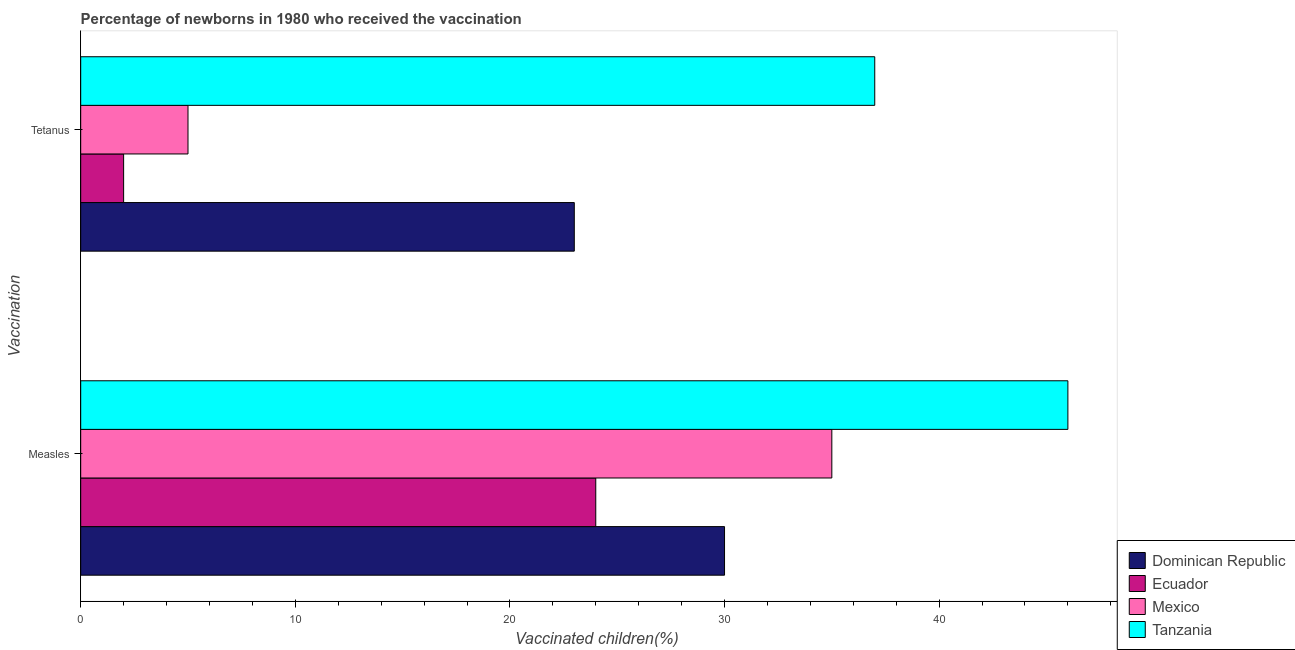How many different coloured bars are there?
Offer a terse response. 4. How many groups of bars are there?
Give a very brief answer. 2. Are the number of bars on each tick of the Y-axis equal?
Make the answer very short. Yes. How many bars are there on the 2nd tick from the bottom?
Provide a short and direct response. 4. What is the label of the 1st group of bars from the top?
Provide a short and direct response. Tetanus. What is the percentage of newborns who received vaccination for tetanus in Tanzania?
Make the answer very short. 37. Across all countries, what is the maximum percentage of newborns who received vaccination for measles?
Offer a terse response. 46. Across all countries, what is the minimum percentage of newborns who received vaccination for tetanus?
Give a very brief answer. 2. In which country was the percentage of newborns who received vaccination for tetanus maximum?
Ensure brevity in your answer.  Tanzania. In which country was the percentage of newborns who received vaccination for measles minimum?
Ensure brevity in your answer.  Ecuador. What is the total percentage of newborns who received vaccination for measles in the graph?
Give a very brief answer. 135. What is the difference between the percentage of newborns who received vaccination for tetanus in Dominican Republic and that in Mexico?
Keep it short and to the point. 18. What is the difference between the percentage of newborns who received vaccination for measles in Ecuador and the percentage of newborns who received vaccination for tetanus in Tanzania?
Keep it short and to the point. -13. What is the average percentage of newborns who received vaccination for measles per country?
Provide a succinct answer. 33.75. What is the difference between the percentage of newborns who received vaccination for measles and percentage of newborns who received vaccination for tetanus in Tanzania?
Offer a very short reply. 9. What is the ratio of the percentage of newborns who received vaccination for measles in Ecuador to that in Tanzania?
Your response must be concise. 0.52. Is the percentage of newborns who received vaccination for tetanus in Dominican Republic less than that in Tanzania?
Keep it short and to the point. Yes. What does the 2nd bar from the bottom in Tetanus represents?
Provide a short and direct response. Ecuador. Does the graph contain any zero values?
Keep it short and to the point. No. Where does the legend appear in the graph?
Your answer should be very brief. Bottom right. How are the legend labels stacked?
Make the answer very short. Vertical. What is the title of the graph?
Give a very brief answer. Percentage of newborns in 1980 who received the vaccination. What is the label or title of the X-axis?
Your answer should be compact. Vaccinated children(%)
. What is the label or title of the Y-axis?
Make the answer very short. Vaccination. What is the Vaccinated children(%)
 in Dominican Republic in Measles?
Ensure brevity in your answer.  30. What is the Vaccinated children(%)
 in Ecuador in Measles?
Give a very brief answer. 24. What is the Vaccinated children(%)
 in Mexico in Measles?
Your response must be concise. 35. Across all Vaccination, what is the maximum Vaccinated children(%)
 of Dominican Republic?
Keep it short and to the point. 30. Across all Vaccination, what is the minimum Vaccinated children(%)
 of Dominican Republic?
Keep it short and to the point. 23. Across all Vaccination, what is the minimum Vaccinated children(%)
 of Tanzania?
Offer a very short reply. 37. What is the total Vaccinated children(%)
 of Dominican Republic in the graph?
Offer a very short reply. 53. What is the total Vaccinated children(%)
 in Ecuador in the graph?
Your answer should be very brief. 26. What is the total Vaccinated children(%)
 in Mexico in the graph?
Make the answer very short. 40. What is the difference between the Vaccinated children(%)
 in Dominican Republic in Measles and that in Tetanus?
Provide a succinct answer. 7. What is the difference between the Vaccinated children(%)
 in Mexico in Measles and that in Tetanus?
Provide a short and direct response. 30. What is the difference between the Vaccinated children(%)
 in Dominican Republic in Measles and the Vaccinated children(%)
 in Ecuador in Tetanus?
Provide a short and direct response. 28. What is the difference between the Vaccinated children(%)
 of Ecuador in Measles and the Vaccinated children(%)
 of Mexico in Tetanus?
Your answer should be very brief. 19. What is the average Vaccinated children(%)
 of Dominican Republic per Vaccination?
Offer a very short reply. 26.5. What is the average Vaccinated children(%)
 of Ecuador per Vaccination?
Give a very brief answer. 13. What is the average Vaccinated children(%)
 of Mexico per Vaccination?
Your answer should be compact. 20. What is the average Vaccinated children(%)
 of Tanzania per Vaccination?
Provide a short and direct response. 41.5. What is the difference between the Vaccinated children(%)
 in Dominican Republic and Vaccinated children(%)
 in Tanzania in Measles?
Offer a very short reply. -16. What is the difference between the Vaccinated children(%)
 of Ecuador and Vaccinated children(%)
 of Mexico in Measles?
Give a very brief answer. -11. What is the difference between the Vaccinated children(%)
 in Dominican Republic and Vaccinated children(%)
 in Tanzania in Tetanus?
Keep it short and to the point. -14. What is the difference between the Vaccinated children(%)
 of Ecuador and Vaccinated children(%)
 of Tanzania in Tetanus?
Provide a succinct answer. -35. What is the difference between the Vaccinated children(%)
 of Mexico and Vaccinated children(%)
 of Tanzania in Tetanus?
Make the answer very short. -32. What is the ratio of the Vaccinated children(%)
 in Dominican Republic in Measles to that in Tetanus?
Ensure brevity in your answer.  1.3. What is the ratio of the Vaccinated children(%)
 of Tanzania in Measles to that in Tetanus?
Offer a very short reply. 1.24. What is the difference between the highest and the second highest Vaccinated children(%)
 of Dominican Republic?
Give a very brief answer. 7. What is the difference between the highest and the lowest Vaccinated children(%)
 of Dominican Republic?
Make the answer very short. 7. What is the difference between the highest and the lowest Vaccinated children(%)
 in Ecuador?
Offer a terse response. 22. 